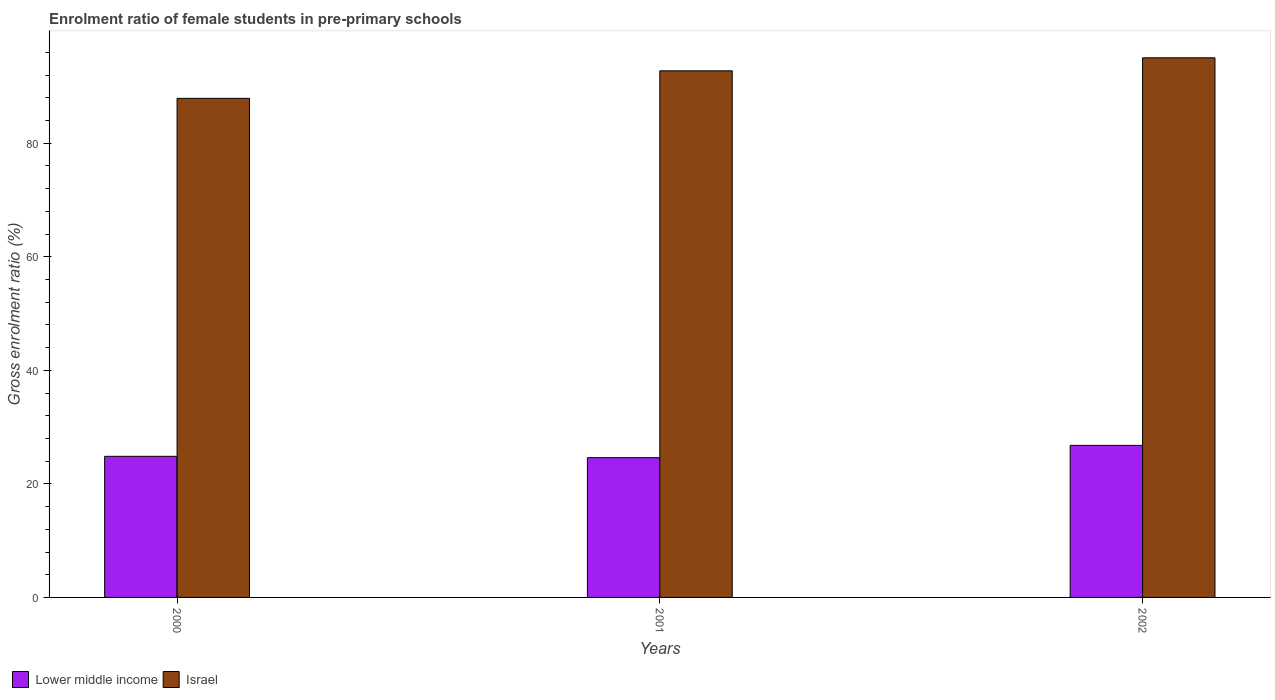Are the number of bars per tick equal to the number of legend labels?
Offer a terse response. Yes. How many bars are there on the 2nd tick from the right?
Your answer should be compact. 2. What is the label of the 1st group of bars from the left?
Offer a very short reply. 2000. What is the enrolment ratio of female students in pre-primary schools in Israel in 2002?
Your response must be concise. 95.04. Across all years, what is the maximum enrolment ratio of female students in pre-primary schools in Lower middle income?
Your response must be concise. 26.78. Across all years, what is the minimum enrolment ratio of female students in pre-primary schools in Israel?
Give a very brief answer. 87.9. In which year was the enrolment ratio of female students in pre-primary schools in Israel maximum?
Make the answer very short. 2002. In which year was the enrolment ratio of female students in pre-primary schools in Lower middle income minimum?
Keep it short and to the point. 2001. What is the total enrolment ratio of female students in pre-primary schools in Lower middle income in the graph?
Ensure brevity in your answer.  76.24. What is the difference between the enrolment ratio of female students in pre-primary schools in Lower middle income in 2000 and that in 2001?
Your response must be concise. 0.24. What is the difference between the enrolment ratio of female students in pre-primary schools in Lower middle income in 2001 and the enrolment ratio of female students in pre-primary schools in Israel in 2002?
Ensure brevity in your answer.  -70.43. What is the average enrolment ratio of female students in pre-primary schools in Israel per year?
Offer a terse response. 91.89. In the year 2002, what is the difference between the enrolment ratio of female students in pre-primary schools in Israel and enrolment ratio of female students in pre-primary schools in Lower middle income?
Offer a terse response. 68.26. What is the ratio of the enrolment ratio of female students in pre-primary schools in Lower middle income in 2001 to that in 2002?
Make the answer very short. 0.92. Is the difference between the enrolment ratio of female students in pre-primary schools in Israel in 2000 and 2002 greater than the difference between the enrolment ratio of female students in pre-primary schools in Lower middle income in 2000 and 2002?
Your response must be concise. No. What is the difference between the highest and the second highest enrolment ratio of female students in pre-primary schools in Israel?
Your answer should be very brief. 2.29. What is the difference between the highest and the lowest enrolment ratio of female students in pre-primary schools in Israel?
Offer a terse response. 7.14. In how many years, is the enrolment ratio of female students in pre-primary schools in Lower middle income greater than the average enrolment ratio of female students in pre-primary schools in Lower middle income taken over all years?
Your answer should be very brief. 1. What does the 2nd bar from the right in 2001 represents?
Keep it short and to the point. Lower middle income. How many bars are there?
Offer a terse response. 6. How many years are there in the graph?
Your response must be concise. 3. What is the difference between two consecutive major ticks on the Y-axis?
Offer a very short reply. 20. Does the graph contain any zero values?
Offer a terse response. No. Does the graph contain grids?
Your response must be concise. No. How many legend labels are there?
Give a very brief answer. 2. What is the title of the graph?
Offer a terse response. Enrolment ratio of female students in pre-primary schools. Does "St. Lucia" appear as one of the legend labels in the graph?
Make the answer very short. No. What is the label or title of the X-axis?
Provide a short and direct response. Years. What is the label or title of the Y-axis?
Provide a succinct answer. Gross enrolment ratio (%). What is the Gross enrolment ratio (%) in Lower middle income in 2000?
Make the answer very short. 24.85. What is the Gross enrolment ratio (%) in Israel in 2000?
Ensure brevity in your answer.  87.9. What is the Gross enrolment ratio (%) of Lower middle income in 2001?
Offer a terse response. 24.61. What is the Gross enrolment ratio (%) in Israel in 2001?
Give a very brief answer. 92.75. What is the Gross enrolment ratio (%) of Lower middle income in 2002?
Provide a short and direct response. 26.78. What is the Gross enrolment ratio (%) of Israel in 2002?
Offer a terse response. 95.04. Across all years, what is the maximum Gross enrolment ratio (%) in Lower middle income?
Your answer should be very brief. 26.78. Across all years, what is the maximum Gross enrolment ratio (%) in Israel?
Offer a very short reply. 95.04. Across all years, what is the minimum Gross enrolment ratio (%) in Lower middle income?
Your answer should be very brief. 24.61. Across all years, what is the minimum Gross enrolment ratio (%) of Israel?
Give a very brief answer. 87.9. What is the total Gross enrolment ratio (%) of Lower middle income in the graph?
Your response must be concise. 76.24. What is the total Gross enrolment ratio (%) of Israel in the graph?
Provide a succinct answer. 275.68. What is the difference between the Gross enrolment ratio (%) in Lower middle income in 2000 and that in 2001?
Provide a succinct answer. 0.24. What is the difference between the Gross enrolment ratio (%) in Israel in 2000 and that in 2001?
Offer a very short reply. -4.85. What is the difference between the Gross enrolment ratio (%) of Lower middle income in 2000 and that in 2002?
Offer a terse response. -1.93. What is the difference between the Gross enrolment ratio (%) of Israel in 2000 and that in 2002?
Your answer should be compact. -7.14. What is the difference between the Gross enrolment ratio (%) of Lower middle income in 2001 and that in 2002?
Give a very brief answer. -2.17. What is the difference between the Gross enrolment ratio (%) of Israel in 2001 and that in 2002?
Your response must be concise. -2.29. What is the difference between the Gross enrolment ratio (%) of Lower middle income in 2000 and the Gross enrolment ratio (%) of Israel in 2001?
Your answer should be very brief. -67.9. What is the difference between the Gross enrolment ratio (%) in Lower middle income in 2000 and the Gross enrolment ratio (%) in Israel in 2002?
Your answer should be compact. -70.19. What is the difference between the Gross enrolment ratio (%) in Lower middle income in 2001 and the Gross enrolment ratio (%) in Israel in 2002?
Your answer should be compact. -70.43. What is the average Gross enrolment ratio (%) of Lower middle income per year?
Provide a short and direct response. 25.41. What is the average Gross enrolment ratio (%) in Israel per year?
Provide a succinct answer. 91.89. In the year 2000, what is the difference between the Gross enrolment ratio (%) of Lower middle income and Gross enrolment ratio (%) of Israel?
Provide a succinct answer. -63.05. In the year 2001, what is the difference between the Gross enrolment ratio (%) of Lower middle income and Gross enrolment ratio (%) of Israel?
Offer a very short reply. -68.13. In the year 2002, what is the difference between the Gross enrolment ratio (%) in Lower middle income and Gross enrolment ratio (%) in Israel?
Ensure brevity in your answer.  -68.26. What is the ratio of the Gross enrolment ratio (%) in Lower middle income in 2000 to that in 2001?
Give a very brief answer. 1.01. What is the ratio of the Gross enrolment ratio (%) of Israel in 2000 to that in 2001?
Your answer should be compact. 0.95. What is the ratio of the Gross enrolment ratio (%) of Lower middle income in 2000 to that in 2002?
Give a very brief answer. 0.93. What is the ratio of the Gross enrolment ratio (%) in Israel in 2000 to that in 2002?
Make the answer very short. 0.92. What is the ratio of the Gross enrolment ratio (%) of Lower middle income in 2001 to that in 2002?
Ensure brevity in your answer.  0.92. What is the ratio of the Gross enrolment ratio (%) of Israel in 2001 to that in 2002?
Your answer should be compact. 0.98. What is the difference between the highest and the second highest Gross enrolment ratio (%) in Lower middle income?
Provide a short and direct response. 1.93. What is the difference between the highest and the second highest Gross enrolment ratio (%) of Israel?
Give a very brief answer. 2.29. What is the difference between the highest and the lowest Gross enrolment ratio (%) of Lower middle income?
Make the answer very short. 2.17. What is the difference between the highest and the lowest Gross enrolment ratio (%) in Israel?
Provide a short and direct response. 7.14. 